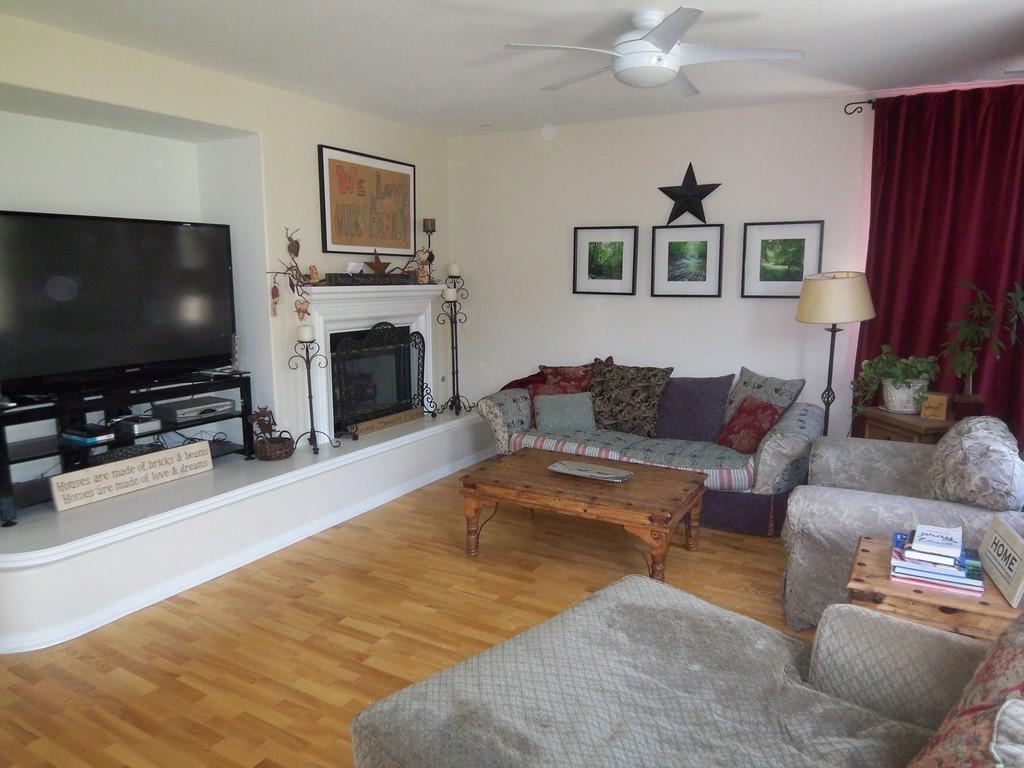Can you describe this image briefly? This is a picture of a hall where there is a couch ,an another couch with 6 pillows and a table where there is a plate , a lamp , 2 plants in the table , some books in the table and left side of the couch there is a television with a stand , a cd player , name board and a fire place and at the back ground there are some candle poles , 3 photo frames and a star attached to the wall , a curtain for the window and a fan attached to the ceiling. 